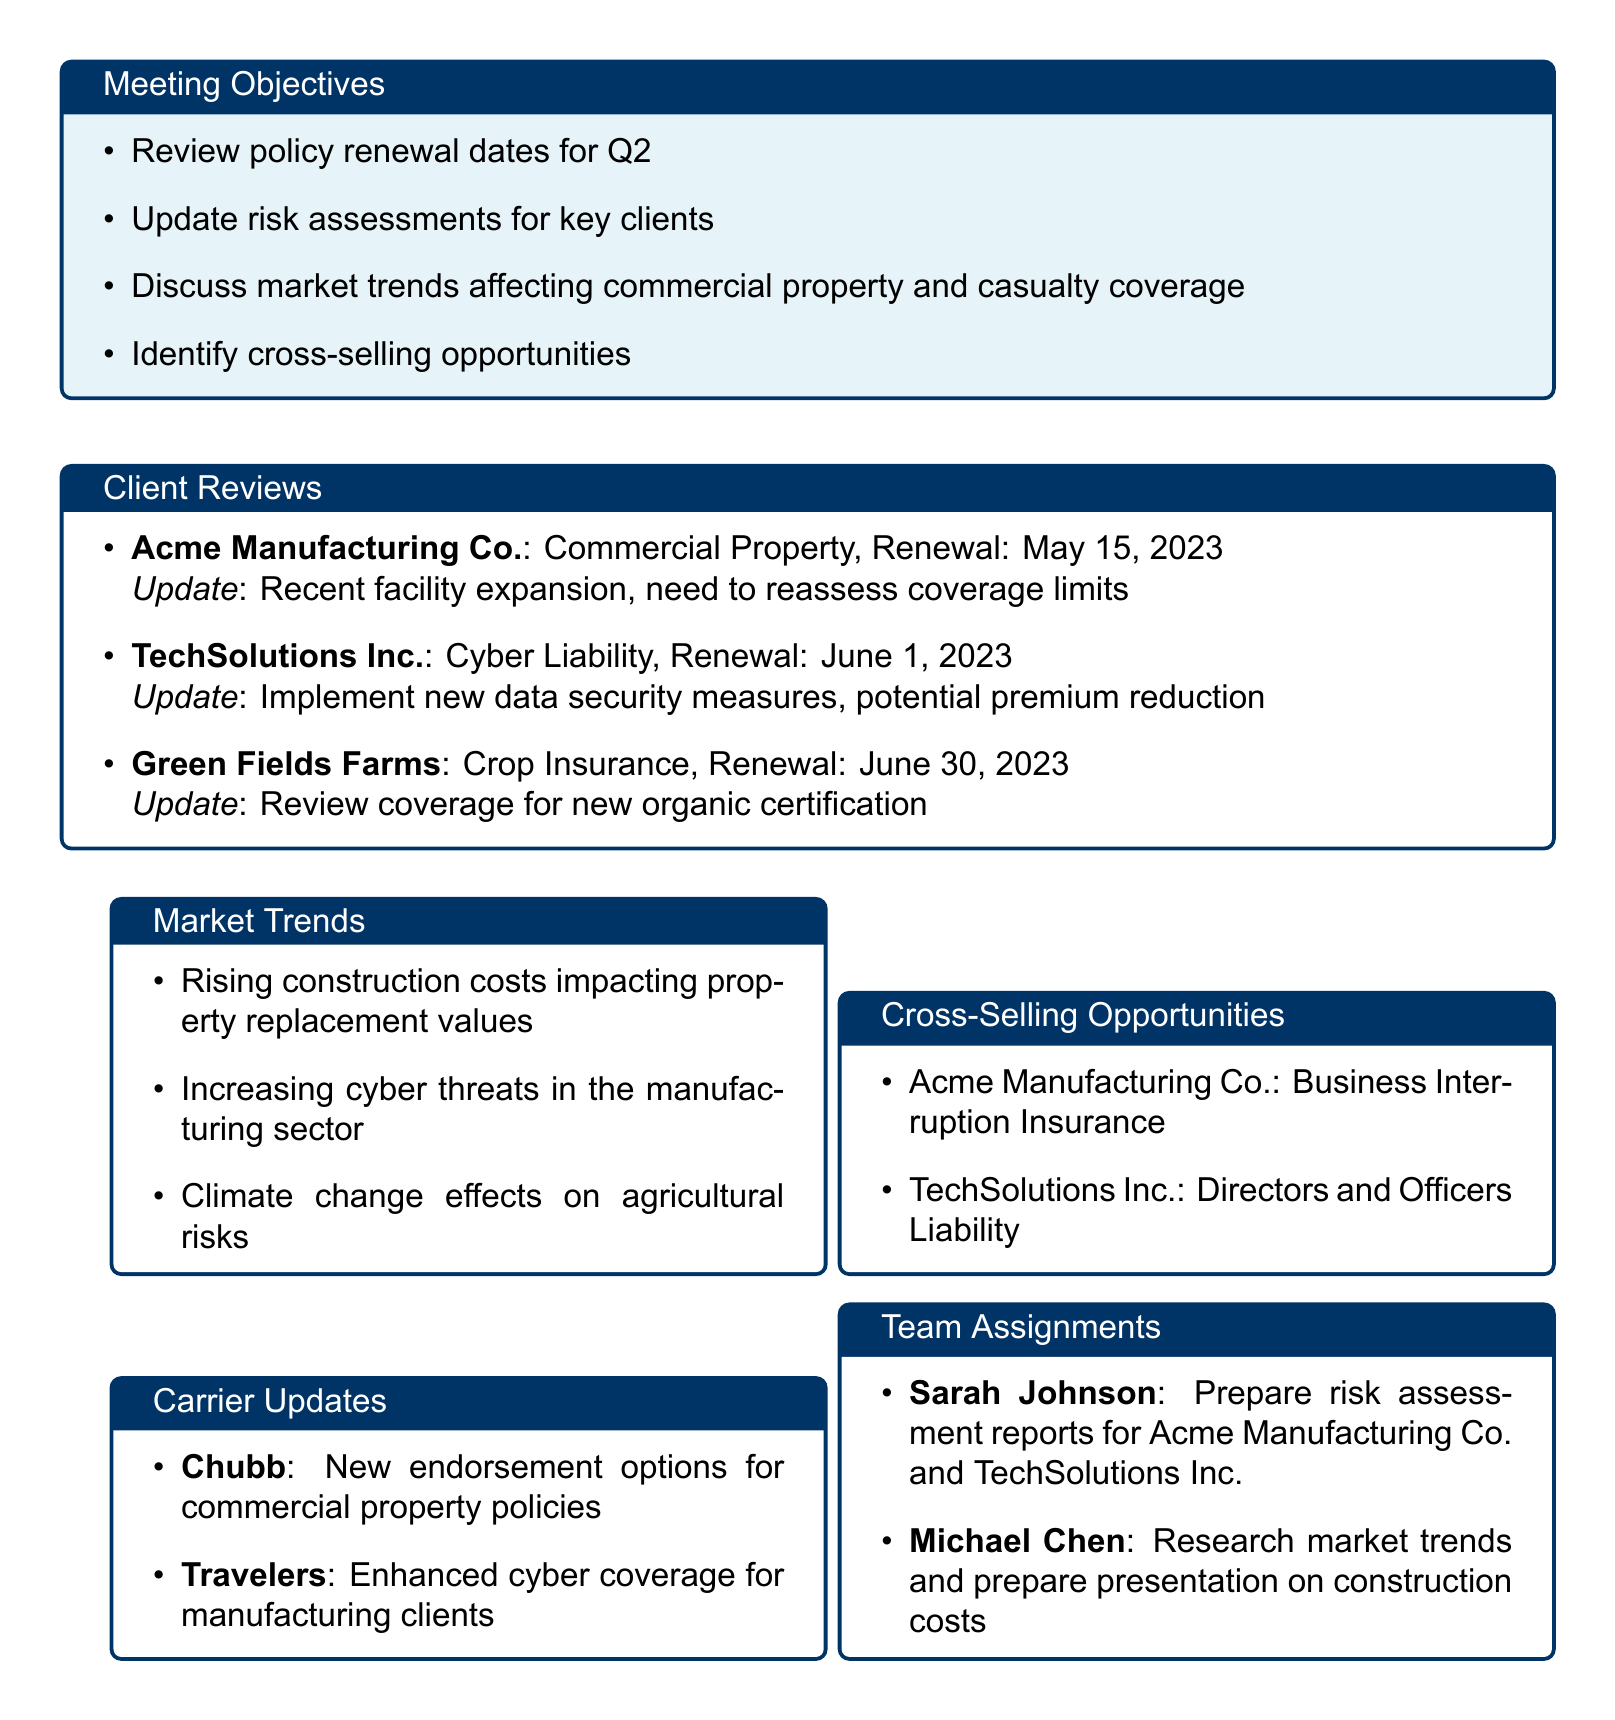What is the meeting title? The meeting title is specified at the top of the document as a heading.
Answer: Q2 Client Review and Policy Renewal Planning When is the renewal date for TechSolutions Inc.? The document lists the renewal dates for each client, including TechSolutions Inc.
Answer: June 1, 2023 What is the risk assessment update for Acme Manufacturing Co.? The document provides updates for each client's risk assessment, highlighting specific changes needed.
Answer: Recent facility expansion, need to reassess coverage limits Which market trend affects agricultural risks? The document describes various market trends, including those specifically impacting agriculture.
Answer: Climate change effects on agricultural risks What potential coverage is suggested for TechSolutions Inc.? This question requires synthesizing information on cross-selling opportunities listed for each client.
Answer: Directors and Officers Liability Who is responsible for preparing risk assessment reports for Acme Manufacturing Co.? The team assignments section details responsibilities for team members related to client reviews.
Answer: Sarah Johnson How many clients have policies renewed in June 2023? This requires counting the clients whose policy renewal dates are in June as listed in the document.
Answer: Two What are the action items related to TechSolutions Inc.? The action items section outlines specific tasks related to each client, including TechSolutions Inc.
Answer: Coordinate with TechSolutions Inc. IT department for cybersecurity assessment What new endorsement options does Chubb offer? The document specifies updates from carriers concerning their policy offerings.
Answer: New endorsement options for commercial property policies 